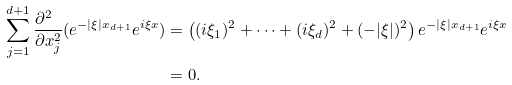<formula> <loc_0><loc_0><loc_500><loc_500>\sum _ { j = 1 } ^ { d + 1 } \frac { \partial ^ { 2 } \ } { \partial x _ { j } ^ { 2 } } ( e ^ { - | \xi | x _ { d + 1 } } e ^ { i \xi x } ) & = \left ( ( i \xi _ { 1 } ) ^ { 2 } + \cdots + ( i \xi _ { d } ) ^ { 2 } + ( - | \xi | ) ^ { 2 } \right ) e ^ { - | \xi | x _ { d + 1 } } e ^ { i \xi x } \\ & = 0 .</formula> 